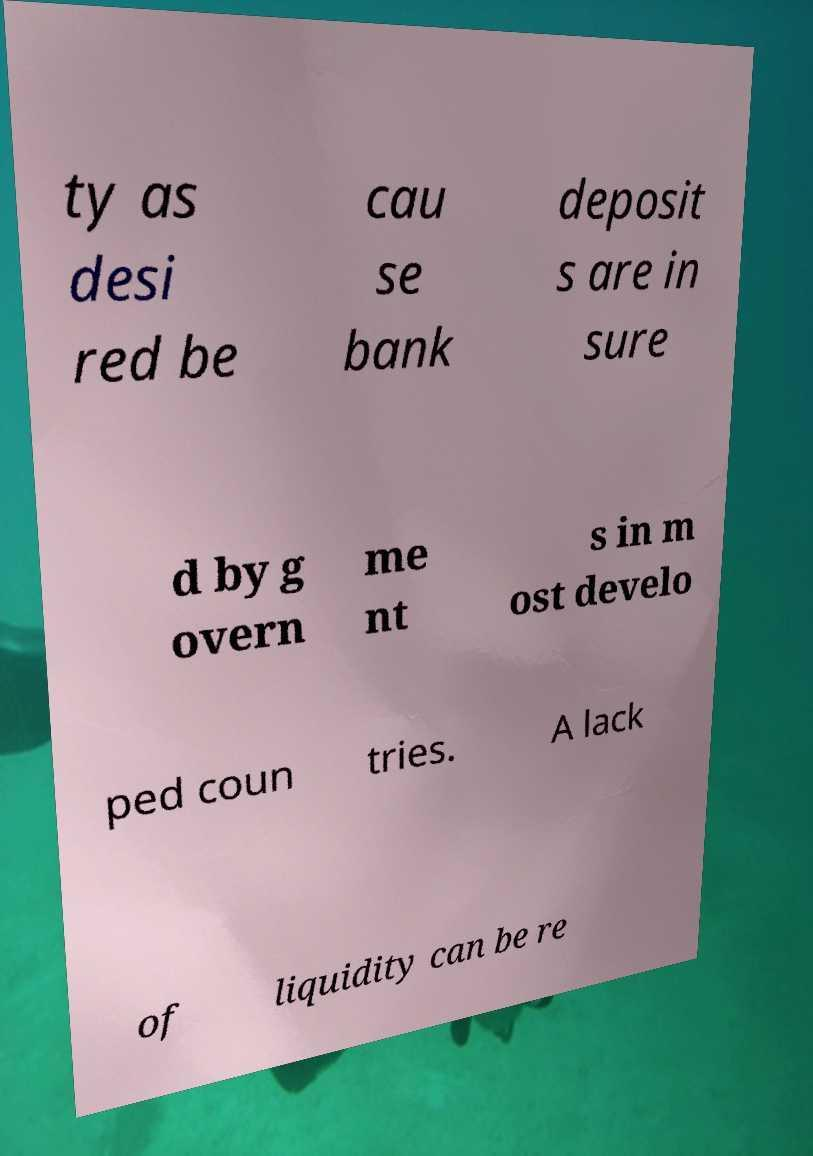What messages or text are displayed in this image? I need them in a readable, typed format. ty as desi red be cau se bank deposit s are in sure d by g overn me nt s in m ost develo ped coun tries. A lack of liquidity can be re 